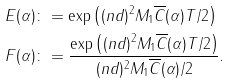Convert formula to latex. <formula><loc_0><loc_0><loc_500><loc_500>E ( \alpha ) & \colon = \exp \left ( ( n d ) ^ { 2 } M _ { 1 } \overline { C } ( \alpha ) T / 2 \right ) \\ F ( \alpha ) & \colon = \frac { \exp \left ( ( n d ) ^ { 2 } M _ { 1 } \overline { C } ( \alpha ) T / 2 \right ) } { ( n d ) ^ { 2 } M _ { 1 } \overline { C } ( \alpha ) / 2 } \text {.}</formula> 